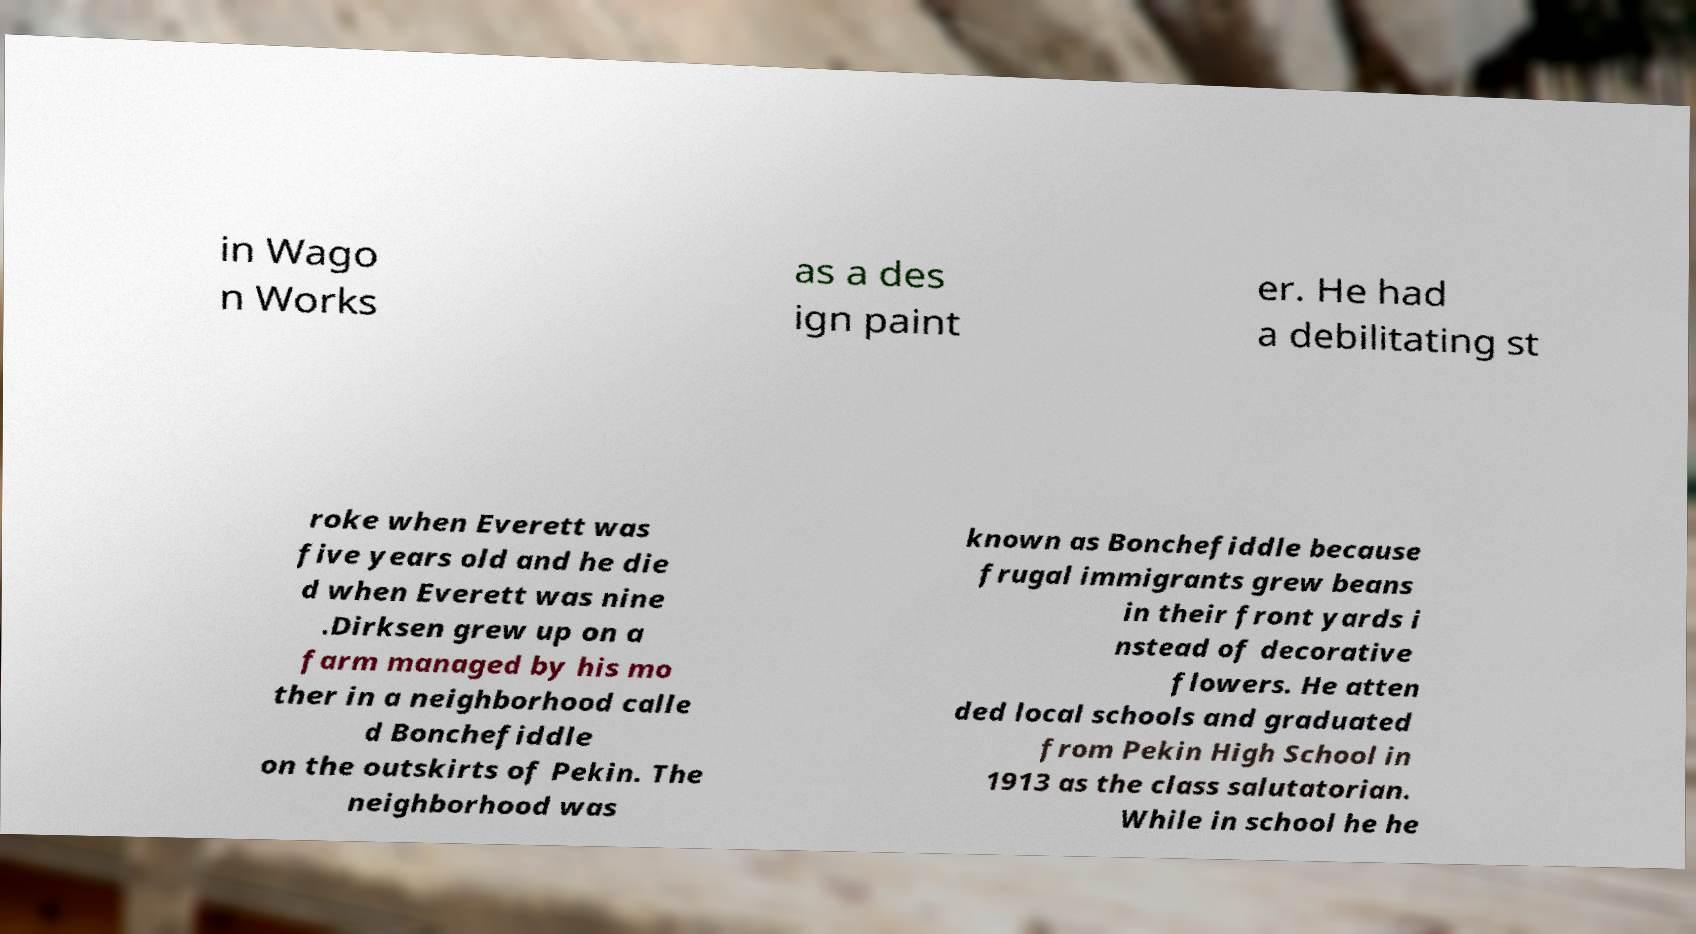What messages or text are displayed in this image? I need them in a readable, typed format. in Wago n Works as a des ign paint er. He had a debilitating st roke when Everett was five years old and he die d when Everett was nine .Dirksen grew up on a farm managed by his mo ther in a neighborhood calle d Bonchefiddle on the outskirts of Pekin. The neighborhood was known as Bonchefiddle because frugal immigrants grew beans in their front yards i nstead of decorative flowers. He atten ded local schools and graduated from Pekin High School in 1913 as the class salutatorian. While in school he he 